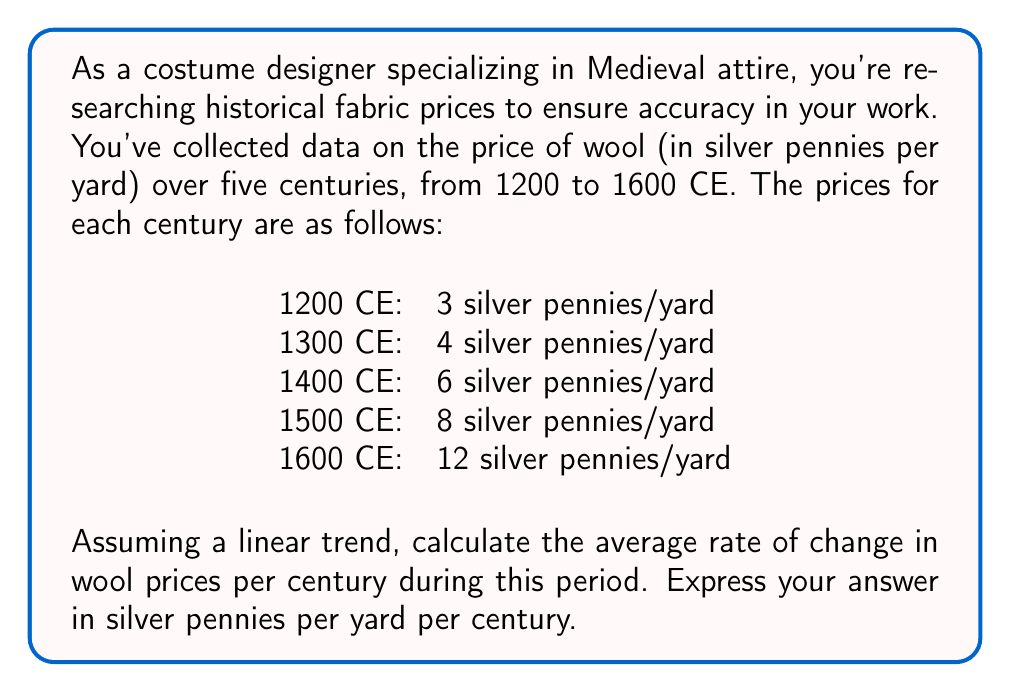What is the answer to this math problem? To solve this problem, we'll use the concept of average rate of change in time series analysis. The average rate of change is calculated by dividing the total change in the dependent variable (price) by the total change in the independent variable (time).

Let's follow these steps:

1. Identify the start and end points:
   Start: 1200 CE, 3 silver pennies/yard
   End: 1600 CE, 12 silver pennies/yard

2. Calculate the total change in price:
   $$\Delta \text{Price} = 12 - 3 = 9 \text{ silver pennies/yard}$$

3. Calculate the total change in time:
   $$\Delta \text{Time} = 1600 - 1200 = 400 \text{ years}$$

4. Convert years to centuries:
   $$400 \text{ years} = 4 \text{ centuries}$$

5. Calculate the average rate of change:
   $$\text{Average Rate of Change} = \frac{\Delta \text{Price}}{\Delta \text{Time (in centuries)}}$$
   
   $$\text{Average Rate of Change} = \frac{9 \text{ silver pennies/yard}}{4 \text{ centuries}}$$
   
   $$\text{Average Rate of Change} = 2.25 \text{ silver pennies/yard/century}$$

This result indicates that, on average, the price of wool increased by 2.25 silver pennies per yard every century from 1200 to 1600 CE.
Answer: 2.25 silver pennies/yard/century 